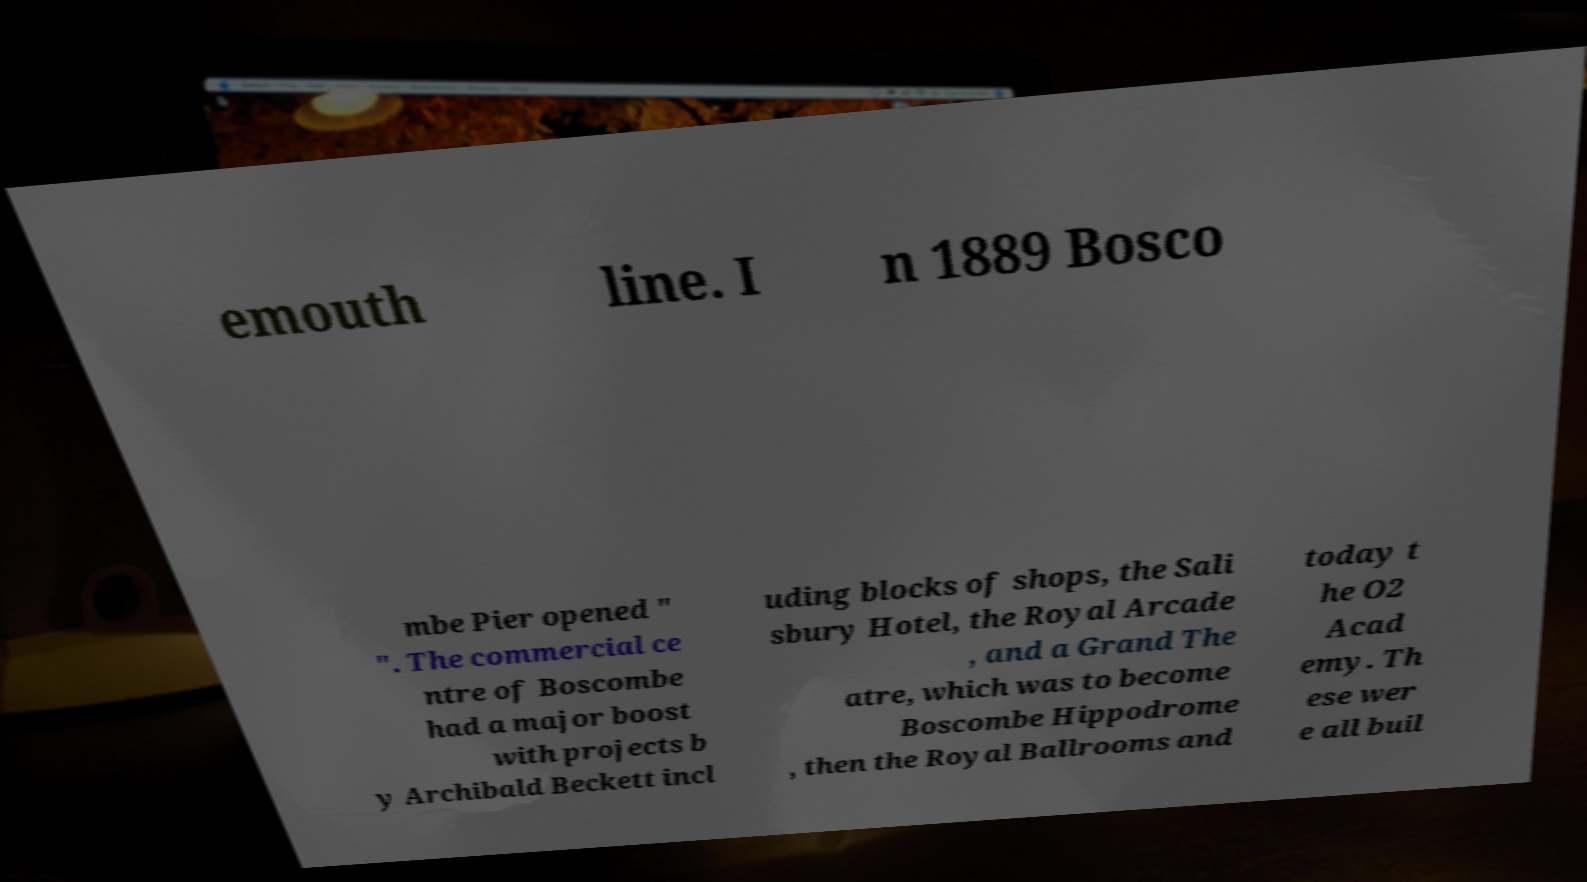For documentation purposes, I need the text within this image transcribed. Could you provide that? emouth line. I n 1889 Bosco mbe Pier opened " ". The commercial ce ntre of Boscombe had a major boost with projects b y Archibald Beckett incl uding blocks of shops, the Sali sbury Hotel, the Royal Arcade , and a Grand The atre, which was to become Boscombe Hippodrome , then the Royal Ballrooms and today t he O2 Acad emy. Th ese wer e all buil 